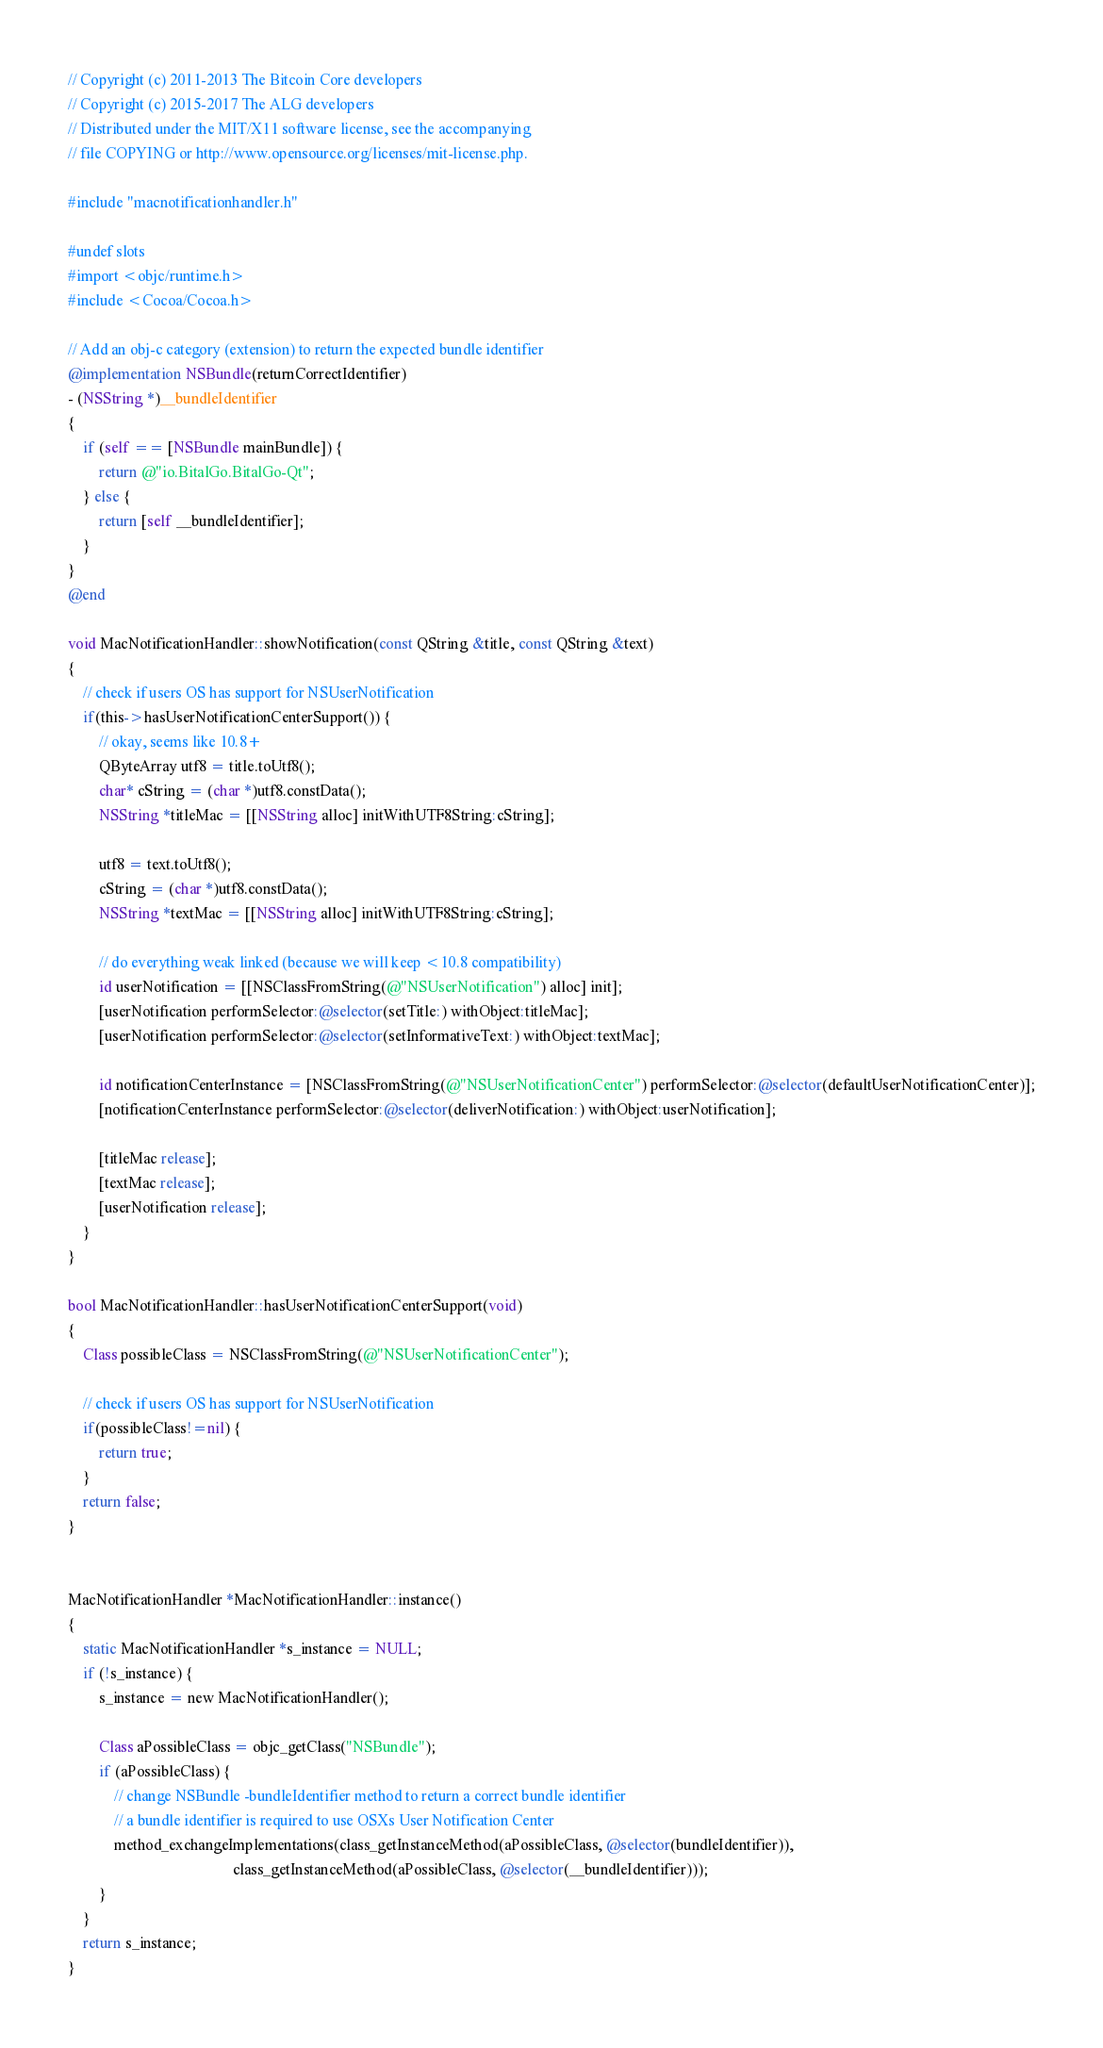Convert code to text. <code><loc_0><loc_0><loc_500><loc_500><_ObjectiveC_>// Copyright (c) 2011-2013 The Bitcoin Core developers
// Copyright (c) 2015-2017 The ALG developers
// Distributed under the MIT/X11 software license, see the accompanying
// file COPYING or http://www.opensource.org/licenses/mit-license.php.

#include "macnotificationhandler.h"

#undef slots
#import <objc/runtime.h>
#include <Cocoa/Cocoa.h>

// Add an obj-c category (extension) to return the expected bundle identifier
@implementation NSBundle(returnCorrectIdentifier)
- (NSString *)__bundleIdentifier
{
    if (self == [NSBundle mainBundle]) {
        return @"io.BitalGo.BitalGo-Qt";
    } else {
        return [self __bundleIdentifier];
    }
}
@end

void MacNotificationHandler::showNotification(const QString &title, const QString &text)
{
    // check if users OS has support for NSUserNotification
    if(this->hasUserNotificationCenterSupport()) {
        // okay, seems like 10.8+
        QByteArray utf8 = title.toUtf8();
        char* cString = (char *)utf8.constData();
        NSString *titleMac = [[NSString alloc] initWithUTF8String:cString];

        utf8 = text.toUtf8();
        cString = (char *)utf8.constData();
        NSString *textMac = [[NSString alloc] initWithUTF8String:cString];

        // do everything weak linked (because we will keep <10.8 compatibility)
        id userNotification = [[NSClassFromString(@"NSUserNotification") alloc] init];
        [userNotification performSelector:@selector(setTitle:) withObject:titleMac];
        [userNotification performSelector:@selector(setInformativeText:) withObject:textMac];

        id notificationCenterInstance = [NSClassFromString(@"NSUserNotificationCenter") performSelector:@selector(defaultUserNotificationCenter)];
        [notificationCenterInstance performSelector:@selector(deliverNotification:) withObject:userNotification];

        [titleMac release];
        [textMac release];
        [userNotification release];
    }
}

bool MacNotificationHandler::hasUserNotificationCenterSupport(void)
{
    Class possibleClass = NSClassFromString(@"NSUserNotificationCenter");

    // check if users OS has support for NSUserNotification
    if(possibleClass!=nil) {
        return true;
    }
    return false;
}


MacNotificationHandler *MacNotificationHandler::instance()
{
    static MacNotificationHandler *s_instance = NULL;
    if (!s_instance) {
        s_instance = new MacNotificationHandler();
        
        Class aPossibleClass = objc_getClass("NSBundle");
        if (aPossibleClass) {
            // change NSBundle -bundleIdentifier method to return a correct bundle identifier
            // a bundle identifier is required to use OSXs User Notification Center
            method_exchangeImplementations(class_getInstanceMethod(aPossibleClass, @selector(bundleIdentifier)),
                                           class_getInstanceMethod(aPossibleClass, @selector(__bundleIdentifier)));
        }
    }
    return s_instance;
}
</code> 